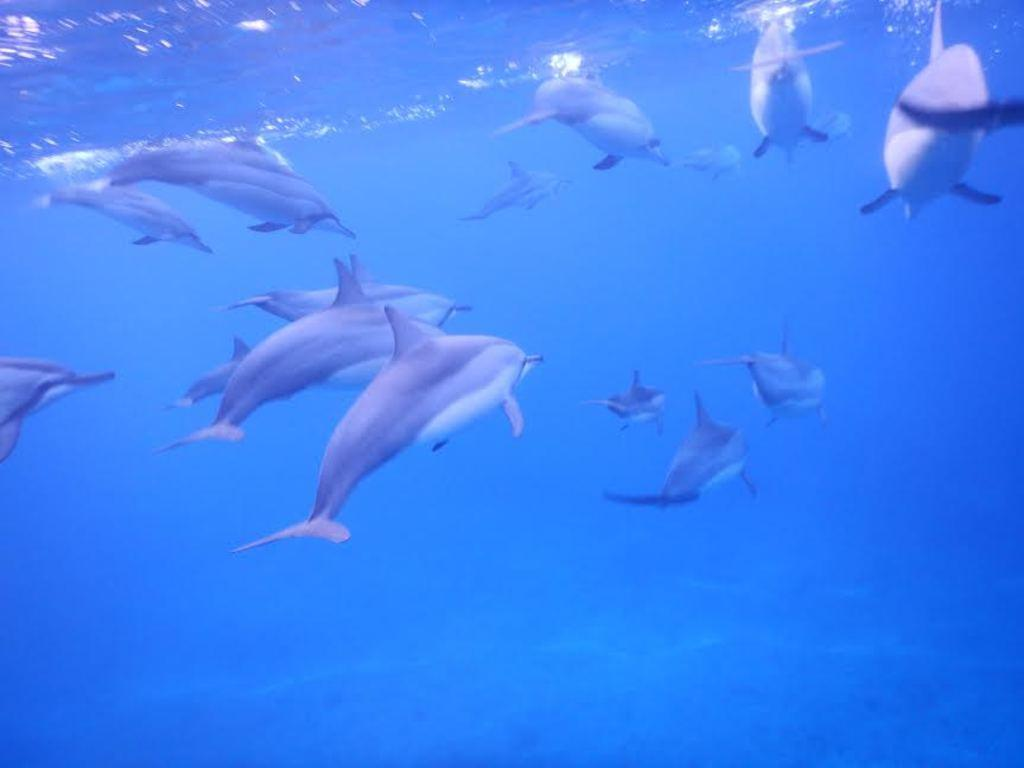What animals are present in the image? There are dolphins in the image. Where are the dolphins located? The dolphins are in water. What type of precipitation can be seen falling from the sky in the image? There is no precipitation visible in the image; it features dolphins in water. How does the dolphin kick its way through the water in the image? The image does not show the dolphin kicking; it only shows the dolphins in the water. 